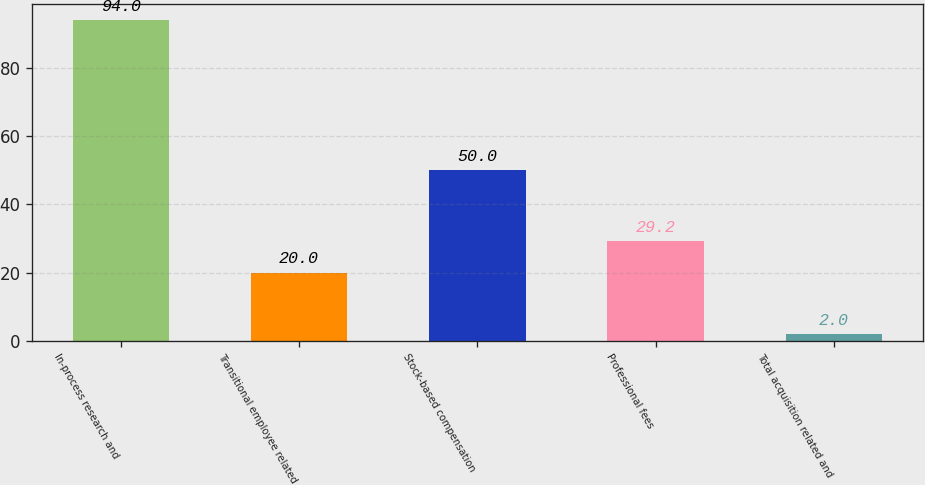Convert chart to OTSL. <chart><loc_0><loc_0><loc_500><loc_500><bar_chart><fcel>In-process research and<fcel>Transitional employee related<fcel>Stock-based compensation<fcel>Professional fees<fcel>Total acquisition related and<nl><fcel>94<fcel>20<fcel>50<fcel>29.2<fcel>2<nl></chart> 